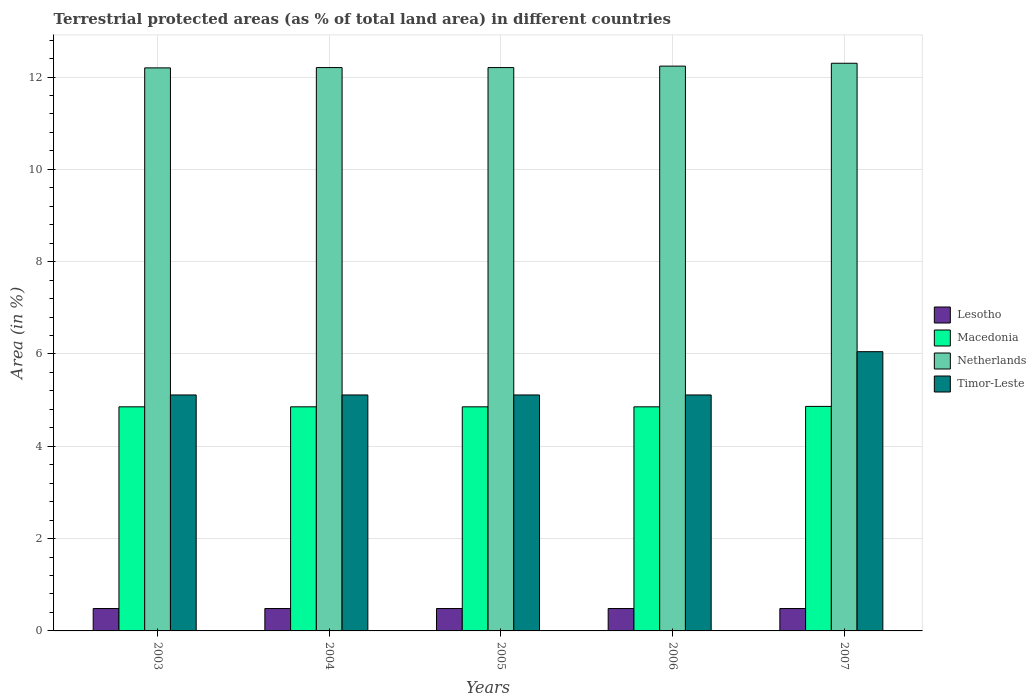How many groups of bars are there?
Give a very brief answer. 5. What is the percentage of terrestrial protected land in Timor-Leste in 2006?
Keep it short and to the point. 5.11. Across all years, what is the maximum percentage of terrestrial protected land in Lesotho?
Make the answer very short. 0.49. Across all years, what is the minimum percentage of terrestrial protected land in Macedonia?
Provide a short and direct response. 4.86. In which year was the percentage of terrestrial protected land in Timor-Leste minimum?
Your answer should be compact. 2003. What is the total percentage of terrestrial protected land in Netherlands in the graph?
Your response must be concise. 61.15. What is the difference between the percentage of terrestrial protected land in Macedonia in 2003 and that in 2007?
Your answer should be very brief. -0.01. What is the difference between the percentage of terrestrial protected land in Timor-Leste in 2007 and the percentage of terrestrial protected land in Macedonia in 2006?
Your answer should be compact. 1.19. What is the average percentage of terrestrial protected land in Lesotho per year?
Your answer should be compact. 0.49. In the year 2005, what is the difference between the percentage of terrestrial protected land in Macedonia and percentage of terrestrial protected land in Timor-Leste?
Ensure brevity in your answer.  -0.26. In how many years, is the percentage of terrestrial protected land in Macedonia greater than 3.2 %?
Provide a succinct answer. 5. What is the ratio of the percentage of terrestrial protected land in Macedonia in 2004 to that in 2006?
Make the answer very short. 1. Is the percentage of terrestrial protected land in Netherlands in 2003 less than that in 2005?
Your answer should be compact. Yes. Is the difference between the percentage of terrestrial protected land in Macedonia in 2004 and 2006 greater than the difference between the percentage of terrestrial protected land in Timor-Leste in 2004 and 2006?
Your answer should be compact. No. What is the difference between the highest and the second highest percentage of terrestrial protected land in Netherlands?
Provide a short and direct response. 0.06. What is the difference between the highest and the lowest percentage of terrestrial protected land in Timor-Leste?
Offer a terse response. 0.94. Is the sum of the percentage of terrestrial protected land in Netherlands in 2003 and 2007 greater than the maximum percentage of terrestrial protected land in Timor-Leste across all years?
Ensure brevity in your answer.  Yes. Is it the case that in every year, the sum of the percentage of terrestrial protected land in Timor-Leste and percentage of terrestrial protected land in Netherlands is greater than the sum of percentage of terrestrial protected land in Macedonia and percentage of terrestrial protected land in Lesotho?
Provide a succinct answer. Yes. What does the 4th bar from the left in 2005 represents?
Keep it short and to the point. Timor-Leste. What does the 2nd bar from the right in 2003 represents?
Offer a very short reply. Netherlands. What is the title of the graph?
Provide a short and direct response. Terrestrial protected areas (as % of total land area) in different countries. Does "Dominica" appear as one of the legend labels in the graph?
Your answer should be very brief. No. What is the label or title of the Y-axis?
Provide a succinct answer. Area (in %). What is the Area (in %) in Lesotho in 2003?
Make the answer very short. 0.49. What is the Area (in %) of Macedonia in 2003?
Provide a short and direct response. 4.86. What is the Area (in %) of Netherlands in 2003?
Your response must be concise. 12.2. What is the Area (in %) in Timor-Leste in 2003?
Your answer should be very brief. 5.11. What is the Area (in %) in Lesotho in 2004?
Offer a terse response. 0.49. What is the Area (in %) in Macedonia in 2004?
Your answer should be very brief. 4.86. What is the Area (in %) in Netherlands in 2004?
Keep it short and to the point. 12.21. What is the Area (in %) of Timor-Leste in 2004?
Provide a succinct answer. 5.11. What is the Area (in %) of Lesotho in 2005?
Your answer should be compact. 0.49. What is the Area (in %) in Macedonia in 2005?
Make the answer very short. 4.86. What is the Area (in %) in Netherlands in 2005?
Provide a succinct answer. 12.21. What is the Area (in %) in Timor-Leste in 2005?
Keep it short and to the point. 5.11. What is the Area (in %) in Lesotho in 2006?
Give a very brief answer. 0.49. What is the Area (in %) in Macedonia in 2006?
Ensure brevity in your answer.  4.86. What is the Area (in %) in Netherlands in 2006?
Offer a terse response. 12.24. What is the Area (in %) of Timor-Leste in 2006?
Ensure brevity in your answer.  5.11. What is the Area (in %) in Lesotho in 2007?
Your answer should be very brief. 0.49. What is the Area (in %) of Macedonia in 2007?
Make the answer very short. 4.86. What is the Area (in %) of Netherlands in 2007?
Your answer should be very brief. 12.3. What is the Area (in %) in Timor-Leste in 2007?
Make the answer very short. 6.05. Across all years, what is the maximum Area (in %) of Lesotho?
Keep it short and to the point. 0.49. Across all years, what is the maximum Area (in %) of Macedonia?
Provide a short and direct response. 4.86. Across all years, what is the maximum Area (in %) in Netherlands?
Give a very brief answer. 12.3. Across all years, what is the maximum Area (in %) of Timor-Leste?
Provide a short and direct response. 6.05. Across all years, what is the minimum Area (in %) in Lesotho?
Give a very brief answer. 0.49. Across all years, what is the minimum Area (in %) of Macedonia?
Make the answer very short. 4.86. Across all years, what is the minimum Area (in %) in Netherlands?
Offer a terse response. 12.2. Across all years, what is the minimum Area (in %) of Timor-Leste?
Your response must be concise. 5.11. What is the total Area (in %) of Lesotho in the graph?
Make the answer very short. 2.43. What is the total Area (in %) in Macedonia in the graph?
Provide a succinct answer. 24.29. What is the total Area (in %) of Netherlands in the graph?
Your response must be concise. 61.15. What is the total Area (in %) in Timor-Leste in the graph?
Your answer should be very brief. 26.5. What is the difference between the Area (in %) of Lesotho in 2003 and that in 2004?
Your response must be concise. 0. What is the difference between the Area (in %) of Macedonia in 2003 and that in 2004?
Give a very brief answer. 0. What is the difference between the Area (in %) in Netherlands in 2003 and that in 2004?
Your answer should be compact. -0.01. What is the difference between the Area (in %) of Timor-Leste in 2003 and that in 2004?
Your answer should be very brief. 0. What is the difference between the Area (in %) in Macedonia in 2003 and that in 2005?
Offer a terse response. 0. What is the difference between the Area (in %) of Netherlands in 2003 and that in 2005?
Make the answer very short. -0.01. What is the difference between the Area (in %) of Timor-Leste in 2003 and that in 2005?
Provide a short and direct response. 0. What is the difference between the Area (in %) in Macedonia in 2003 and that in 2006?
Ensure brevity in your answer.  0. What is the difference between the Area (in %) in Netherlands in 2003 and that in 2006?
Make the answer very short. -0.04. What is the difference between the Area (in %) of Timor-Leste in 2003 and that in 2006?
Offer a very short reply. 0. What is the difference between the Area (in %) of Macedonia in 2003 and that in 2007?
Your answer should be very brief. -0.01. What is the difference between the Area (in %) in Netherlands in 2003 and that in 2007?
Make the answer very short. -0.1. What is the difference between the Area (in %) in Timor-Leste in 2003 and that in 2007?
Offer a terse response. -0.94. What is the difference between the Area (in %) of Lesotho in 2004 and that in 2005?
Your response must be concise. 0. What is the difference between the Area (in %) of Timor-Leste in 2004 and that in 2005?
Your response must be concise. 0. What is the difference between the Area (in %) of Lesotho in 2004 and that in 2006?
Make the answer very short. 0. What is the difference between the Area (in %) of Macedonia in 2004 and that in 2006?
Offer a very short reply. 0. What is the difference between the Area (in %) in Netherlands in 2004 and that in 2006?
Keep it short and to the point. -0.03. What is the difference between the Area (in %) in Timor-Leste in 2004 and that in 2006?
Keep it short and to the point. 0. What is the difference between the Area (in %) in Lesotho in 2004 and that in 2007?
Make the answer very short. 0. What is the difference between the Area (in %) in Macedonia in 2004 and that in 2007?
Your answer should be very brief. -0.01. What is the difference between the Area (in %) of Netherlands in 2004 and that in 2007?
Keep it short and to the point. -0.09. What is the difference between the Area (in %) in Timor-Leste in 2004 and that in 2007?
Make the answer very short. -0.94. What is the difference between the Area (in %) of Lesotho in 2005 and that in 2006?
Provide a succinct answer. 0. What is the difference between the Area (in %) in Macedonia in 2005 and that in 2006?
Offer a terse response. 0. What is the difference between the Area (in %) of Netherlands in 2005 and that in 2006?
Give a very brief answer. -0.03. What is the difference between the Area (in %) in Macedonia in 2005 and that in 2007?
Your response must be concise. -0.01. What is the difference between the Area (in %) in Netherlands in 2005 and that in 2007?
Give a very brief answer. -0.09. What is the difference between the Area (in %) of Timor-Leste in 2005 and that in 2007?
Provide a short and direct response. -0.94. What is the difference between the Area (in %) of Lesotho in 2006 and that in 2007?
Make the answer very short. 0. What is the difference between the Area (in %) of Macedonia in 2006 and that in 2007?
Offer a terse response. -0.01. What is the difference between the Area (in %) in Netherlands in 2006 and that in 2007?
Your answer should be compact. -0.06. What is the difference between the Area (in %) of Timor-Leste in 2006 and that in 2007?
Make the answer very short. -0.94. What is the difference between the Area (in %) in Lesotho in 2003 and the Area (in %) in Macedonia in 2004?
Provide a succinct answer. -4.37. What is the difference between the Area (in %) of Lesotho in 2003 and the Area (in %) of Netherlands in 2004?
Your response must be concise. -11.72. What is the difference between the Area (in %) of Lesotho in 2003 and the Area (in %) of Timor-Leste in 2004?
Give a very brief answer. -4.63. What is the difference between the Area (in %) in Macedonia in 2003 and the Area (in %) in Netherlands in 2004?
Ensure brevity in your answer.  -7.35. What is the difference between the Area (in %) in Macedonia in 2003 and the Area (in %) in Timor-Leste in 2004?
Offer a very short reply. -0.26. What is the difference between the Area (in %) in Netherlands in 2003 and the Area (in %) in Timor-Leste in 2004?
Your response must be concise. 7.09. What is the difference between the Area (in %) of Lesotho in 2003 and the Area (in %) of Macedonia in 2005?
Provide a succinct answer. -4.37. What is the difference between the Area (in %) of Lesotho in 2003 and the Area (in %) of Netherlands in 2005?
Offer a terse response. -11.72. What is the difference between the Area (in %) in Lesotho in 2003 and the Area (in %) in Timor-Leste in 2005?
Offer a very short reply. -4.63. What is the difference between the Area (in %) of Macedonia in 2003 and the Area (in %) of Netherlands in 2005?
Your response must be concise. -7.35. What is the difference between the Area (in %) in Macedonia in 2003 and the Area (in %) in Timor-Leste in 2005?
Give a very brief answer. -0.26. What is the difference between the Area (in %) of Netherlands in 2003 and the Area (in %) of Timor-Leste in 2005?
Provide a succinct answer. 7.09. What is the difference between the Area (in %) in Lesotho in 2003 and the Area (in %) in Macedonia in 2006?
Offer a terse response. -4.37. What is the difference between the Area (in %) in Lesotho in 2003 and the Area (in %) in Netherlands in 2006?
Provide a short and direct response. -11.75. What is the difference between the Area (in %) in Lesotho in 2003 and the Area (in %) in Timor-Leste in 2006?
Provide a short and direct response. -4.63. What is the difference between the Area (in %) in Macedonia in 2003 and the Area (in %) in Netherlands in 2006?
Give a very brief answer. -7.38. What is the difference between the Area (in %) of Macedonia in 2003 and the Area (in %) of Timor-Leste in 2006?
Provide a succinct answer. -0.26. What is the difference between the Area (in %) of Netherlands in 2003 and the Area (in %) of Timor-Leste in 2006?
Your answer should be very brief. 7.09. What is the difference between the Area (in %) in Lesotho in 2003 and the Area (in %) in Macedonia in 2007?
Provide a succinct answer. -4.38. What is the difference between the Area (in %) in Lesotho in 2003 and the Area (in %) in Netherlands in 2007?
Your answer should be very brief. -11.81. What is the difference between the Area (in %) in Lesotho in 2003 and the Area (in %) in Timor-Leste in 2007?
Offer a very short reply. -5.56. What is the difference between the Area (in %) in Macedonia in 2003 and the Area (in %) in Netherlands in 2007?
Ensure brevity in your answer.  -7.44. What is the difference between the Area (in %) in Macedonia in 2003 and the Area (in %) in Timor-Leste in 2007?
Provide a succinct answer. -1.19. What is the difference between the Area (in %) in Netherlands in 2003 and the Area (in %) in Timor-Leste in 2007?
Offer a terse response. 6.15. What is the difference between the Area (in %) of Lesotho in 2004 and the Area (in %) of Macedonia in 2005?
Your answer should be compact. -4.37. What is the difference between the Area (in %) of Lesotho in 2004 and the Area (in %) of Netherlands in 2005?
Make the answer very short. -11.72. What is the difference between the Area (in %) of Lesotho in 2004 and the Area (in %) of Timor-Leste in 2005?
Give a very brief answer. -4.63. What is the difference between the Area (in %) in Macedonia in 2004 and the Area (in %) in Netherlands in 2005?
Give a very brief answer. -7.35. What is the difference between the Area (in %) of Macedonia in 2004 and the Area (in %) of Timor-Leste in 2005?
Provide a short and direct response. -0.26. What is the difference between the Area (in %) of Netherlands in 2004 and the Area (in %) of Timor-Leste in 2005?
Provide a short and direct response. 7.09. What is the difference between the Area (in %) in Lesotho in 2004 and the Area (in %) in Macedonia in 2006?
Provide a short and direct response. -4.37. What is the difference between the Area (in %) of Lesotho in 2004 and the Area (in %) of Netherlands in 2006?
Give a very brief answer. -11.75. What is the difference between the Area (in %) of Lesotho in 2004 and the Area (in %) of Timor-Leste in 2006?
Give a very brief answer. -4.63. What is the difference between the Area (in %) in Macedonia in 2004 and the Area (in %) in Netherlands in 2006?
Your answer should be compact. -7.38. What is the difference between the Area (in %) in Macedonia in 2004 and the Area (in %) in Timor-Leste in 2006?
Offer a very short reply. -0.26. What is the difference between the Area (in %) of Netherlands in 2004 and the Area (in %) of Timor-Leste in 2006?
Your answer should be compact. 7.09. What is the difference between the Area (in %) of Lesotho in 2004 and the Area (in %) of Macedonia in 2007?
Your answer should be very brief. -4.38. What is the difference between the Area (in %) of Lesotho in 2004 and the Area (in %) of Netherlands in 2007?
Your answer should be compact. -11.81. What is the difference between the Area (in %) of Lesotho in 2004 and the Area (in %) of Timor-Leste in 2007?
Your answer should be very brief. -5.56. What is the difference between the Area (in %) of Macedonia in 2004 and the Area (in %) of Netherlands in 2007?
Your answer should be compact. -7.44. What is the difference between the Area (in %) of Macedonia in 2004 and the Area (in %) of Timor-Leste in 2007?
Your response must be concise. -1.19. What is the difference between the Area (in %) in Netherlands in 2004 and the Area (in %) in Timor-Leste in 2007?
Give a very brief answer. 6.16. What is the difference between the Area (in %) in Lesotho in 2005 and the Area (in %) in Macedonia in 2006?
Your response must be concise. -4.37. What is the difference between the Area (in %) of Lesotho in 2005 and the Area (in %) of Netherlands in 2006?
Ensure brevity in your answer.  -11.75. What is the difference between the Area (in %) in Lesotho in 2005 and the Area (in %) in Timor-Leste in 2006?
Keep it short and to the point. -4.63. What is the difference between the Area (in %) of Macedonia in 2005 and the Area (in %) of Netherlands in 2006?
Ensure brevity in your answer.  -7.38. What is the difference between the Area (in %) in Macedonia in 2005 and the Area (in %) in Timor-Leste in 2006?
Ensure brevity in your answer.  -0.26. What is the difference between the Area (in %) of Netherlands in 2005 and the Area (in %) of Timor-Leste in 2006?
Offer a terse response. 7.09. What is the difference between the Area (in %) in Lesotho in 2005 and the Area (in %) in Macedonia in 2007?
Offer a very short reply. -4.38. What is the difference between the Area (in %) of Lesotho in 2005 and the Area (in %) of Netherlands in 2007?
Ensure brevity in your answer.  -11.81. What is the difference between the Area (in %) in Lesotho in 2005 and the Area (in %) in Timor-Leste in 2007?
Your answer should be very brief. -5.56. What is the difference between the Area (in %) of Macedonia in 2005 and the Area (in %) of Netherlands in 2007?
Offer a terse response. -7.44. What is the difference between the Area (in %) of Macedonia in 2005 and the Area (in %) of Timor-Leste in 2007?
Your answer should be very brief. -1.19. What is the difference between the Area (in %) in Netherlands in 2005 and the Area (in %) in Timor-Leste in 2007?
Make the answer very short. 6.16. What is the difference between the Area (in %) in Lesotho in 2006 and the Area (in %) in Macedonia in 2007?
Your answer should be compact. -4.38. What is the difference between the Area (in %) in Lesotho in 2006 and the Area (in %) in Netherlands in 2007?
Provide a short and direct response. -11.81. What is the difference between the Area (in %) in Lesotho in 2006 and the Area (in %) in Timor-Leste in 2007?
Your answer should be very brief. -5.56. What is the difference between the Area (in %) of Macedonia in 2006 and the Area (in %) of Netherlands in 2007?
Your answer should be compact. -7.44. What is the difference between the Area (in %) of Macedonia in 2006 and the Area (in %) of Timor-Leste in 2007?
Your response must be concise. -1.19. What is the difference between the Area (in %) of Netherlands in 2006 and the Area (in %) of Timor-Leste in 2007?
Your answer should be very brief. 6.19. What is the average Area (in %) in Lesotho per year?
Your answer should be very brief. 0.49. What is the average Area (in %) in Macedonia per year?
Give a very brief answer. 4.86. What is the average Area (in %) of Netherlands per year?
Your answer should be compact. 12.23. What is the average Area (in %) of Timor-Leste per year?
Make the answer very short. 5.3. In the year 2003, what is the difference between the Area (in %) in Lesotho and Area (in %) in Macedonia?
Ensure brevity in your answer.  -4.37. In the year 2003, what is the difference between the Area (in %) of Lesotho and Area (in %) of Netherlands?
Make the answer very short. -11.71. In the year 2003, what is the difference between the Area (in %) in Lesotho and Area (in %) in Timor-Leste?
Your answer should be very brief. -4.63. In the year 2003, what is the difference between the Area (in %) in Macedonia and Area (in %) in Netherlands?
Your response must be concise. -7.34. In the year 2003, what is the difference between the Area (in %) in Macedonia and Area (in %) in Timor-Leste?
Your response must be concise. -0.26. In the year 2003, what is the difference between the Area (in %) of Netherlands and Area (in %) of Timor-Leste?
Offer a very short reply. 7.09. In the year 2004, what is the difference between the Area (in %) in Lesotho and Area (in %) in Macedonia?
Offer a terse response. -4.37. In the year 2004, what is the difference between the Area (in %) in Lesotho and Area (in %) in Netherlands?
Your answer should be compact. -11.72. In the year 2004, what is the difference between the Area (in %) of Lesotho and Area (in %) of Timor-Leste?
Your answer should be compact. -4.63. In the year 2004, what is the difference between the Area (in %) in Macedonia and Area (in %) in Netherlands?
Your answer should be very brief. -7.35. In the year 2004, what is the difference between the Area (in %) of Macedonia and Area (in %) of Timor-Leste?
Your answer should be compact. -0.26. In the year 2004, what is the difference between the Area (in %) of Netherlands and Area (in %) of Timor-Leste?
Your response must be concise. 7.09. In the year 2005, what is the difference between the Area (in %) in Lesotho and Area (in %) in Macedonia?
Your answer should be very brief. -4.37. In the year 2005, what is the difference between the Area (in %) of Lesotho and Area (in %) of Netherlands?
Keep it short and to the point. -11.72. In the year 2005, what is the difference between the Area (in %) in Lesotho and Area (in %) in Timor-Leste?
Ensure brevity in your answer.  -4.63. In the year 2005, what is the difference between the Area (in %) in Macedonia and Area (in %) in Netherlands?
Provide a short and direct response. -7.35. In the year 2005, what is the difference between the Area (in %) in Macedonia and Area (in %) in Timor-Leste?
Give a very brief answer. -0.26. In the year 2005, what is the difference between the Area (in %) in Netherlands and Area (in %) in Timor-Leste?
Provide a succinct answer. 7.09. In the year 2006, what is the difference between the Area (in %) in Lesotho and Area (in %) in Macedonia?
Keep it short and to the point. -4.37. In the year 2006, what is the difference between the Area (in %) in Lesotho and Area (in %) in Netherlands?
Give a very brief answer. -11.75. In the year 2006, what is the difference between the Area (in %) in Lesotho and Area (in %) in Timor-Leste?
Offer a very short reply. -4.63. In the year 2006, what is the difference between the Area (in %) of Macedonia and Area (in %) of Netherlands?
Make the answer very short. -7.38. In the year 2006, what is the difference between the Area (in %) of Macedonia and Area (in %) of Timor-Leste?
Give a very brief answer. -0.26. In the year 2006, what is the difference between the Area (in %) in Netherlands and Area (in %) in Timor-Leste?
Your response must be concise. 7.13. In the year 2007, what is the difference between the Area (in %) in Lesotho and Area (in %) in Macedonia?
Ensure brevity in your answer.  -4.38. In the year 2007, what is the difference between the Area (in %) in Lesotho and Area (in %) in Netherlands?
Offer a terse response. -11.81. In the year 2007, what is the difference between the Area (in %) in Lesotho and Area (in %) in Timor-Leste?
Offer a very short reply. -5.56. In the year 2007, what is the difference between the Area (in %) in Macedonia and Area (in %) in Netherlands?
Ensure brevity in your answer.  -7.43. In the year 2007, what is the difference between the Area (in %) of Macedonia and Area (in %) of Timor-Leste?
Provide a short and direct response. -1.19. In the year 2007, what is the difference between the Area (in %) in Netherlands and Area (in %) in Timor-Leste?
Your answer should be compact. 6.25. What is the ratio of the Area (in %) of Lesotho in 2003 to that in 2004?
Your answer should be compact. 1. What is the ratio of the Area (in %) in Timor-Leste in 2003 to that in 2005?
Provide a succinct answer. 1. What is the ratio of the Area (in %) of Macedonia in 2003 to that in 2006?
Ensure brevity in your answer.  1. What is the ratio of the Area (in %) of Netherlands in 2003 to that in 2006?
Make the answer very short. 1. What is the ratio of the Area (in %) in Timor-Leste in 2003 to that in 2006?
Offer a very short reply. 1. What is the ratio of the Area (in %) in Lesotho in 2003 to that in 2007?
Provide a succinct answer. 1. What is the ratio of the Area (in %) of Macedonia in 2003 to that in 2007?
Your answer should be compact. 1. What is the ratio of the Area (in %) of Timor-Leste in 2003 to that in 2007?
Offer a very short reply. 0.84. What is the ratio of the Area (in %) of Netherlands in 2004 to that in 2005?
Provide a succinct answer. 1. What is the ratio of the Area (in %) of Lesotho in 2004 to that in 2006?
Make the answer very short. 1. What is the ratio of the Area (in %) of Macedonia in 2004 to that in 2006?
Offer a very short reply. 1. What is the ratio of the Area (in %) of Lesotho in 2004 to that in 2007?
Make the answer very short. 1. What is the ratio of the Area (in %) of Timor-Leste in 2004 to that in 2007?
Ensure brevity in your answer.  0.84. What is the ratio of the Area (in %) of Lesotho in 2005 to that in 2006?
Your answer should be very brief. 1. What is the ratio of the Area (in %) of Macedonia in 2005 to that in 2006?
Ensure brevity in your answer.  1. What is the ratio of the Area (in %) of Timor-Leste in 2005 to that in 2006?
Your answer should be very brief. 1. What is the ratio of the Area (in %) of Lesotho in 2005 to that in 2007?
Provide a succinct answer. 1. What is the ratio of the Area (in %) of Netherlands in 2005 to that in 2007?
Provide a short and direct response. 0.99. What is the ratio of the Area (in %) of Timor-Leste in 2005 to that in 2007?
Make the answer very short. 0.84. What is the ratio of the Area (in %) of Lesotho in 2006 to that in 2007?
Give a very brief answer. 1. What is the ratio of the Area (in %) in Macedonia in 2006 to that in 2007?
Keep it short and to the point. 1. What is the ratio of the Area (in %) of Timor-Leste in 2006 to that in 2007?
Your answer should be very brief. 0.84. What is the difference between the highest and the second highest Area (in %) in Macedonia?
Your answer should be compact. 0.01. What is the difference between the highest and the second highest Area (in %) in Netherlands?
Give a very brief answer. 0.06. What is the difference between the highest and the second highest Area (in %) in Timor-Leste?
Provide a short and direct response. 0.94. What is the difference between the highest and the lowest Area (in %) of Lesotho?
Make the answer very short. 0. What is the difference between the highest and the lowest Area (in %) of Macedonia?
Make the answer very short. 0.01. What is the difference between the highest and the lowest Area (in %) in Netherlands?
Ensure brevity in your answer.  0.1. What is the difference between the highest and the lowest Area (in %) of Timor-Leste?
Ensure brevity in your answer.  0.94. 